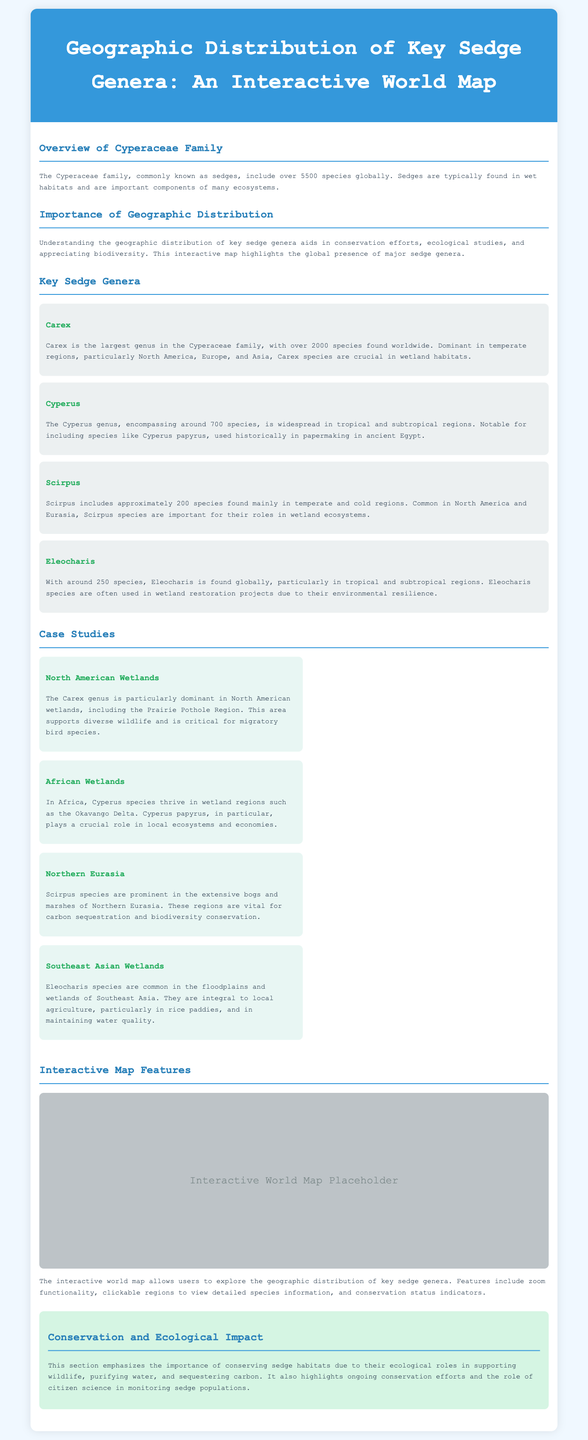What is the largest genus in the Cyperaceae family? The document states that Carex is the largest genus in the Cyperaceae family, with over 2000 species found worldwide.
Answer: Carex How many species does the Cyperus genus encompass? According to the document, the Cyperus genus encompasses around 700 species.
Answer: 700 Which region is particularly dominant for the Carex genus? The document mentions that Carex species are dominant in temperate regions, particularly North America, Europe, and Asia.
Answer: North America What role does Cyperus papyrus play in African ecosystems? The document states that Cyperus papyrus plays a crucial role in local ecosystems and economies, particularly in wetland regions such as the Okavango Delta.
Answer: Crucial role Which genera are commonly found in Southeast Asian wetlands? The document indicates that Eleocharis species are common in the floodplains and wetlands of Southeast Asia.
Answer: Eleocharis What is one feature of the interactive world map mentioned? The document highlights features such as zoom functionality and clickable regions to view detailed species information.
Answer: Zoom functionality How many species of Eleocharis are found globally? It is stated in the document that there are around 250 species of Eleocharis globally.
Answer: 250 What ecological role do sedge habitats play? The document emphasizes that sedge habitats support wildlife, purify water, and sequester carbon.
Answer: Support wildlife Which key genus is dominant in Northern Eurasia? According to the document, Scirpus species are prominent in Northern Eurasia.
Answer: Scirpus 